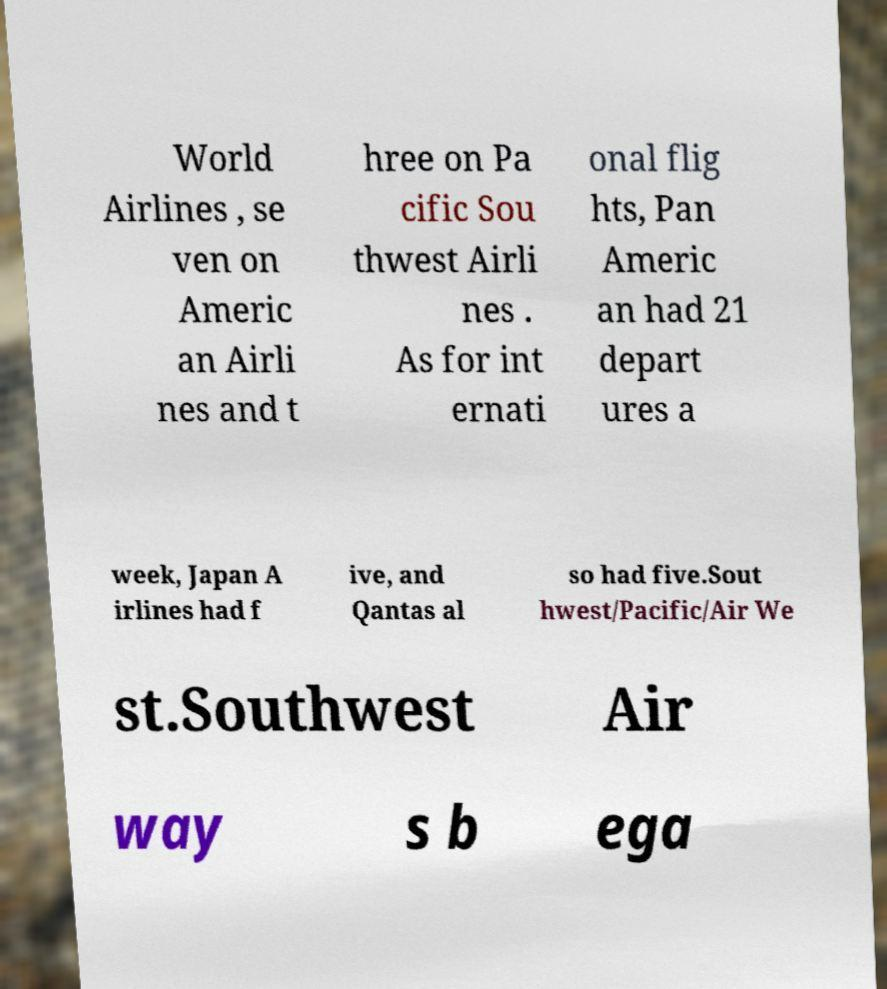Can you accurately transcribe the text from the provided image for me? World Airlines , se ven on Americ an Airli nes and t hree on Pa cific Sou thwest Airli nes . As for int ernati onal flig hts, Pan Americ an had 21 depart ures a week, Japan A irlines had f ive, and Qantas al so had five.Sout hwest/Pacific/Air We st.Southwest Air way s b ega 